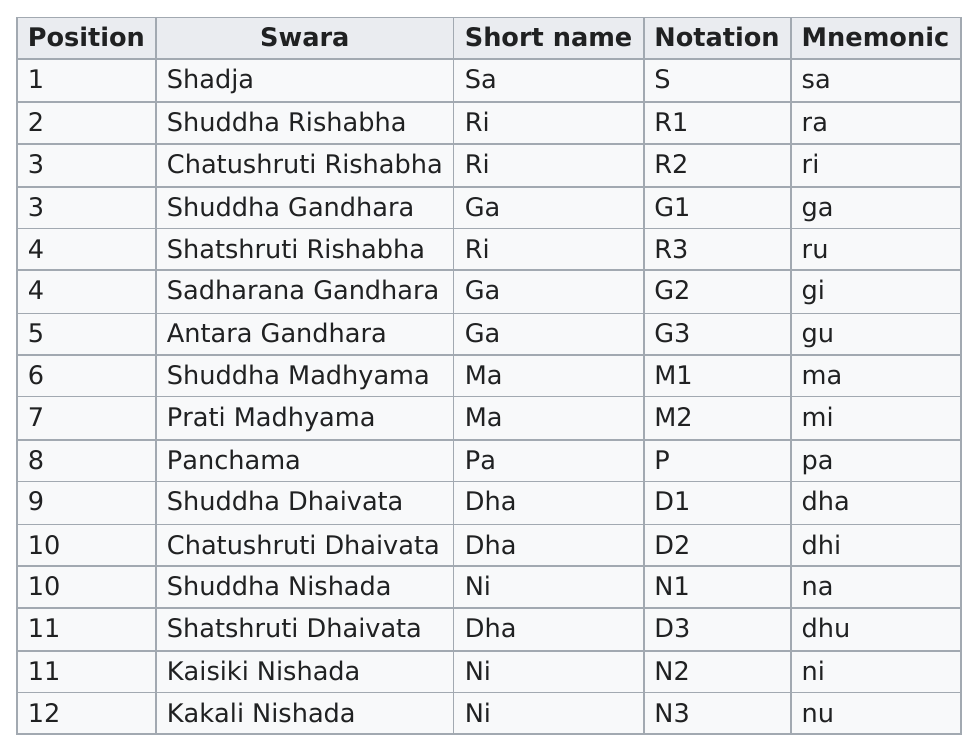List a handful of essential elements in this visual. The last swara with Dha as their short name is Shatshruti Dhaivata. On average, six out of every ten Swara have a short name that begins with the letters D or G. The notations for the first three consecutive swaras are S, R1, and R2. I will find the 9th position swara and determine its short name, which is Dha. The swara that holds the last position is Kakali Nishada. 